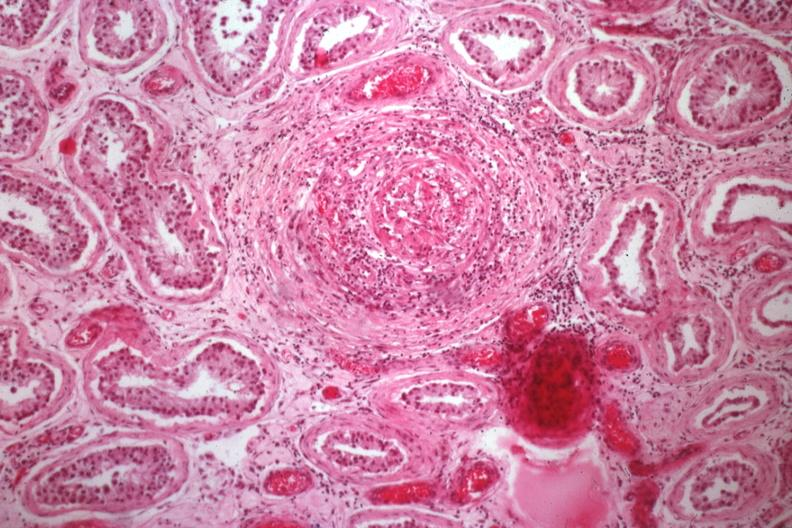what does this image show?
Answer the question using a single word or phrase. Medium size artery with obvious vasculitis 